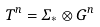Convert formula to latex. <formula><loc_0><loc_0><loc_500><loc_500>T ^ { n } = \Sigma _ { * } \otimes G ^ { n }</formula> 